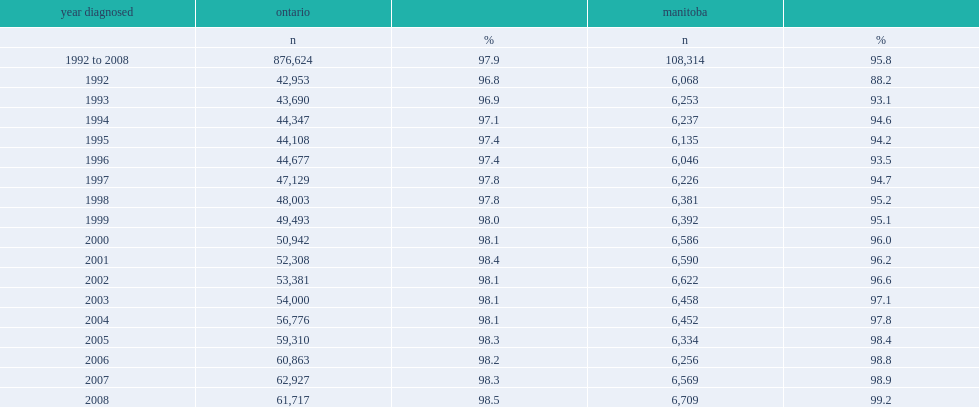I'm looking to parse the entire table for insights. Could you assist me with that? {'header': ['year diagnosed', 'ontario', '', 'manitoba', ''], 'rows': [['', 'n', '%', 'n', '%'], ['1992 to 2008', '876,624', '97.9', '108,314', '95.8'], ['1992', '42,953', '96.8', '6,068', '88.2'], ['1993', '43,690', '96.9', '6,253', '93.1'], ['1994', '44,347', '97.1', '6,237', '94.6'], ['1995', '44,108', '97.4', '6,135', '94.2'], ['1996', '44,677', '97.4', '6,046', '93.5'], ['1997', '47,129', '97.8', '6,226', '94.7'], ['1998', '48,003', '97.8', '6,381', '95.2'], ['1999', '49,493', '98.0', '6,392', '95.1'], ['2000', '50,942', '98.1', '6,586', '96.0'], ['2001', '52,308', '98.4', '6,590', '96.2'], ['2002', '53,381', '98.1', '6,622', '96.6'], ['2003', '54,000', '98.1', '6,458', '97.1'], ['2004', '56,776', '98.1', '6,452', '97.8'], ['2005', '59,310', '98.3', '6,334', '98.4'], ['2006', '60,863', '98.2', '6,256', '98.8'], ['2007', '62,927', '98.3', '6,569', '98.9'], ['2008', '61,717', '98.5', '6,709', '99.2']]} What were the percentages of tumours probabilistically linked to a hin in the respective health insurance registries for ontario and manitoba respectively? 97.9 95.8. Which year did the percentage of tumours with a valid hin exceeded 98% in both ontario and manitoba? 2005.0. 